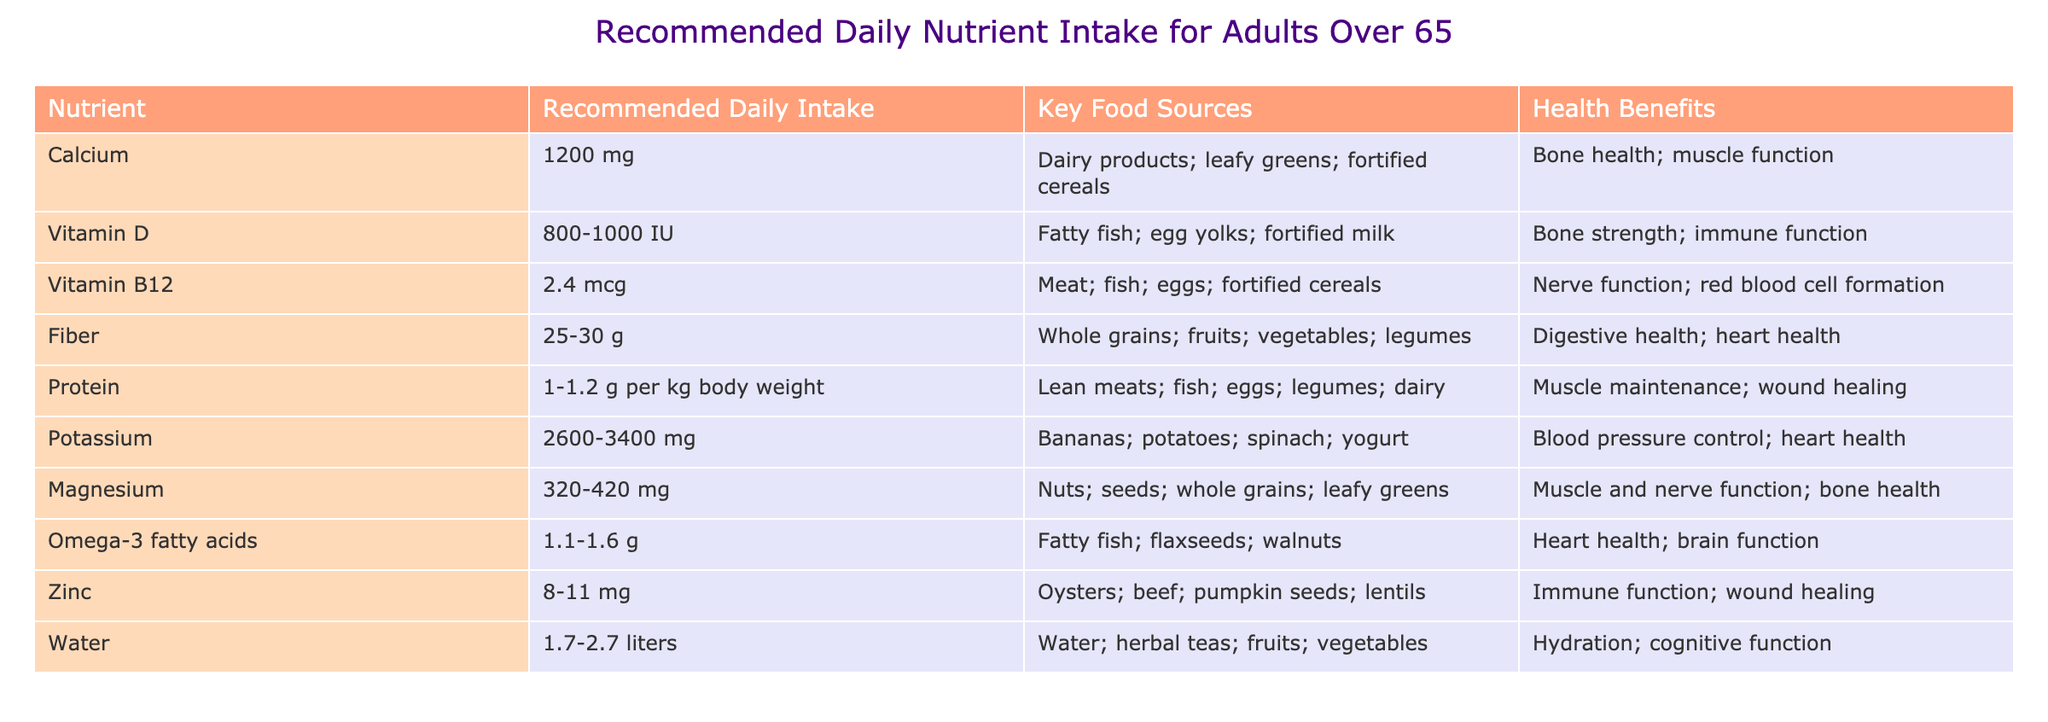What is the recommended daily intake of Calcium for adults over 65? The table indicates that the recommended daily intake of Calcium is 1200 mg.
Answer: 1200 mg Which nutrient has a recommended daily intake range of 800-1000 IU? According to the table, Vitamin D is the nutrient with a recommended daily intake range of 800-1000 IU.
Answer: Vitamin D What are the key food sources for Magnesium? The table lists nuts, seeds, whole grains, and leafy greens as the key food sources for Magnesium.
Answer: Nuts, seeds, whole grains, leafy greens Is the recommended daily intake of Zinc more than 10 mg? The table shows that the recommended daily intake of Zinc ranges from 8 to 11 mg, indicating that it is not consistently more than 10 mg.
Answer: No On average, what is the combined recommended daily intake of Calcium and Vitamin B12? The recommended daily intake of Calcium is 1200 mg and Vitamin B12 is 2.4 mcg. Converting 1200 mg to mcg gives 1200000 mcg. Adding both gives: 1200000 mcg + 2.4 mcg = 1200002.4 mcg.
Answer: 1200002.4 mcg Which nutrients have health benefits related to heart health? Referring to the table, the nutrients with health benefits related to heart health are Fiber, Potassium, and Omega-3 fatty acids.
Answer: Fiber, Potassium, Omega-3 fatty acids How much more Protein is recommended compared to the minimum value of Omega-3 fatty acids? The Protein intake is 1-1.2 g per kg of body weight. The minimum Omega-3 fatty acids recommended is 1.1 g. The total is indeterminate without knowing body weight, but for examples sake, if it were based on 70 kg, Protein min would be 70 g; thus, 70 g - 1.1 g = 68.9 g more protein, but this varies based on weight.
Answer: Variable based on weight Identify a nutrient that supports cognitive function. The table indicates that Water supports cognitive function among other benefits.
Answer: Water What nutrient contributes to muscle and nerve function? According to the table, Magnesium is identified as contributing to muscle and nerve function.
Answer: Magnesium 